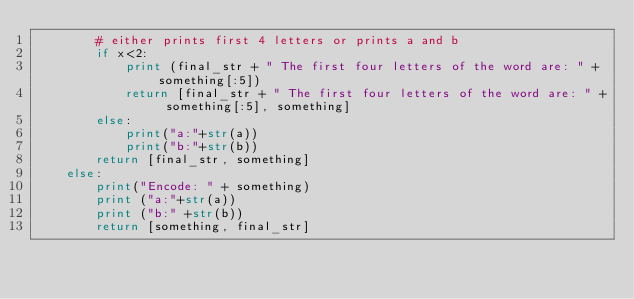Convert code to text. <code><loc_0><loc_0><loc_500><loc_500><_Python_>        # either prints first 4 letters or prints a and b
        if x<2:
            print (final_str + " The first four letters of the word are: " + something[:5])
            return [final_str + " The first four letters of the word are: " + something[:5], something]
        else:
            print("a:"+str(a))
            print("b:"+str(b))
        return [final_str, something]
    else:
        print("Encode: " + something)
        print ("a:"+str(a))
        print ("b:" +str(b))
        return [something, final_str]

</code> 